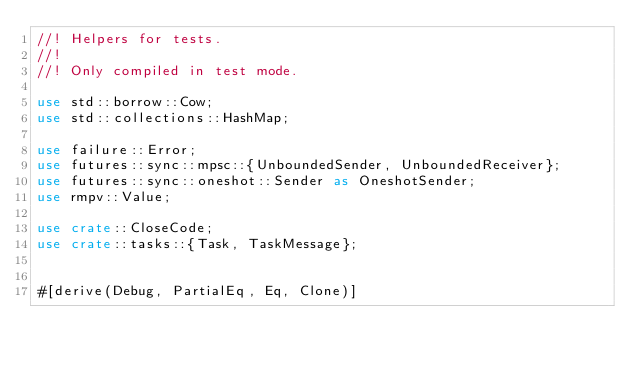<code> <loc_0><loc_0><loc_500><loc_500><_Rust_>//! Helpers for tests.
//!
//! Only compiled in test mode.

use std::borrow::Cow;
use std::collections::HashMap;

use failure::Error;
use futures::sync::mpsc::{UnboundedSender, UnboundedReceiver};
use futures::sync::oneshot::Sender as OneshotSender;
use rmpv::Value;

use crate::CloseCode;
use crate::tasks::{Task, TaskMessage};


#[derive(Debug, PartialEq, Eq, Clone)]</code> 